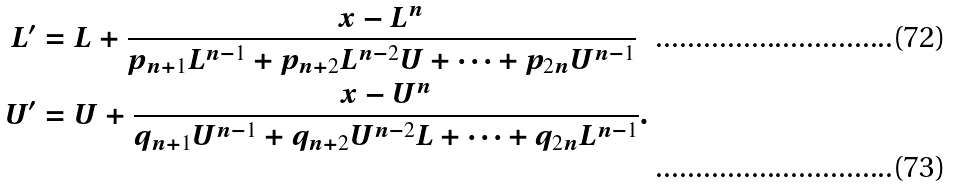Convert formula to latex. <formula><loc_0><loc_0><loc_500><loc_500>L ^ { \prime } & = L + \frac { x - L ^ { n } } { p _ { n + 1 } L ^ { n - 1 } + p _ { n + 2 } L ^ { n - 2 } U + \cdots + p _ { 2 n } U ^ { n - 1 } } \\ U ^ { \prime } & = U + \frac { x - U ^ { n } } { q _ { n + 1 } U ^ { n - 1 } + q _ { n + 2 } U ^ { n - 2 } L + \cdots + q _ { 2 n } L ^ { n - 1 } } .</formula> 